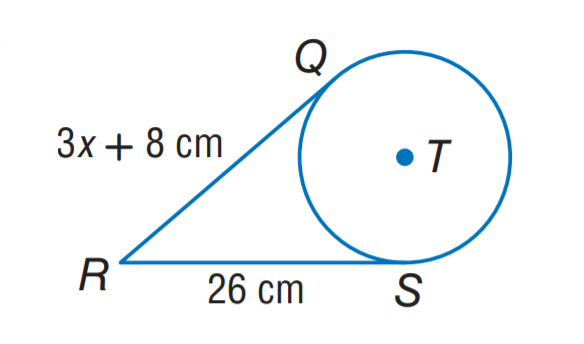Answer the mathemtical geometry problem and directly provide the correct option letter.
Question: The segment is tangent to the circle. Find the value of x.
Choices: A: 6 B: 8 C: 12 D: 26 A 